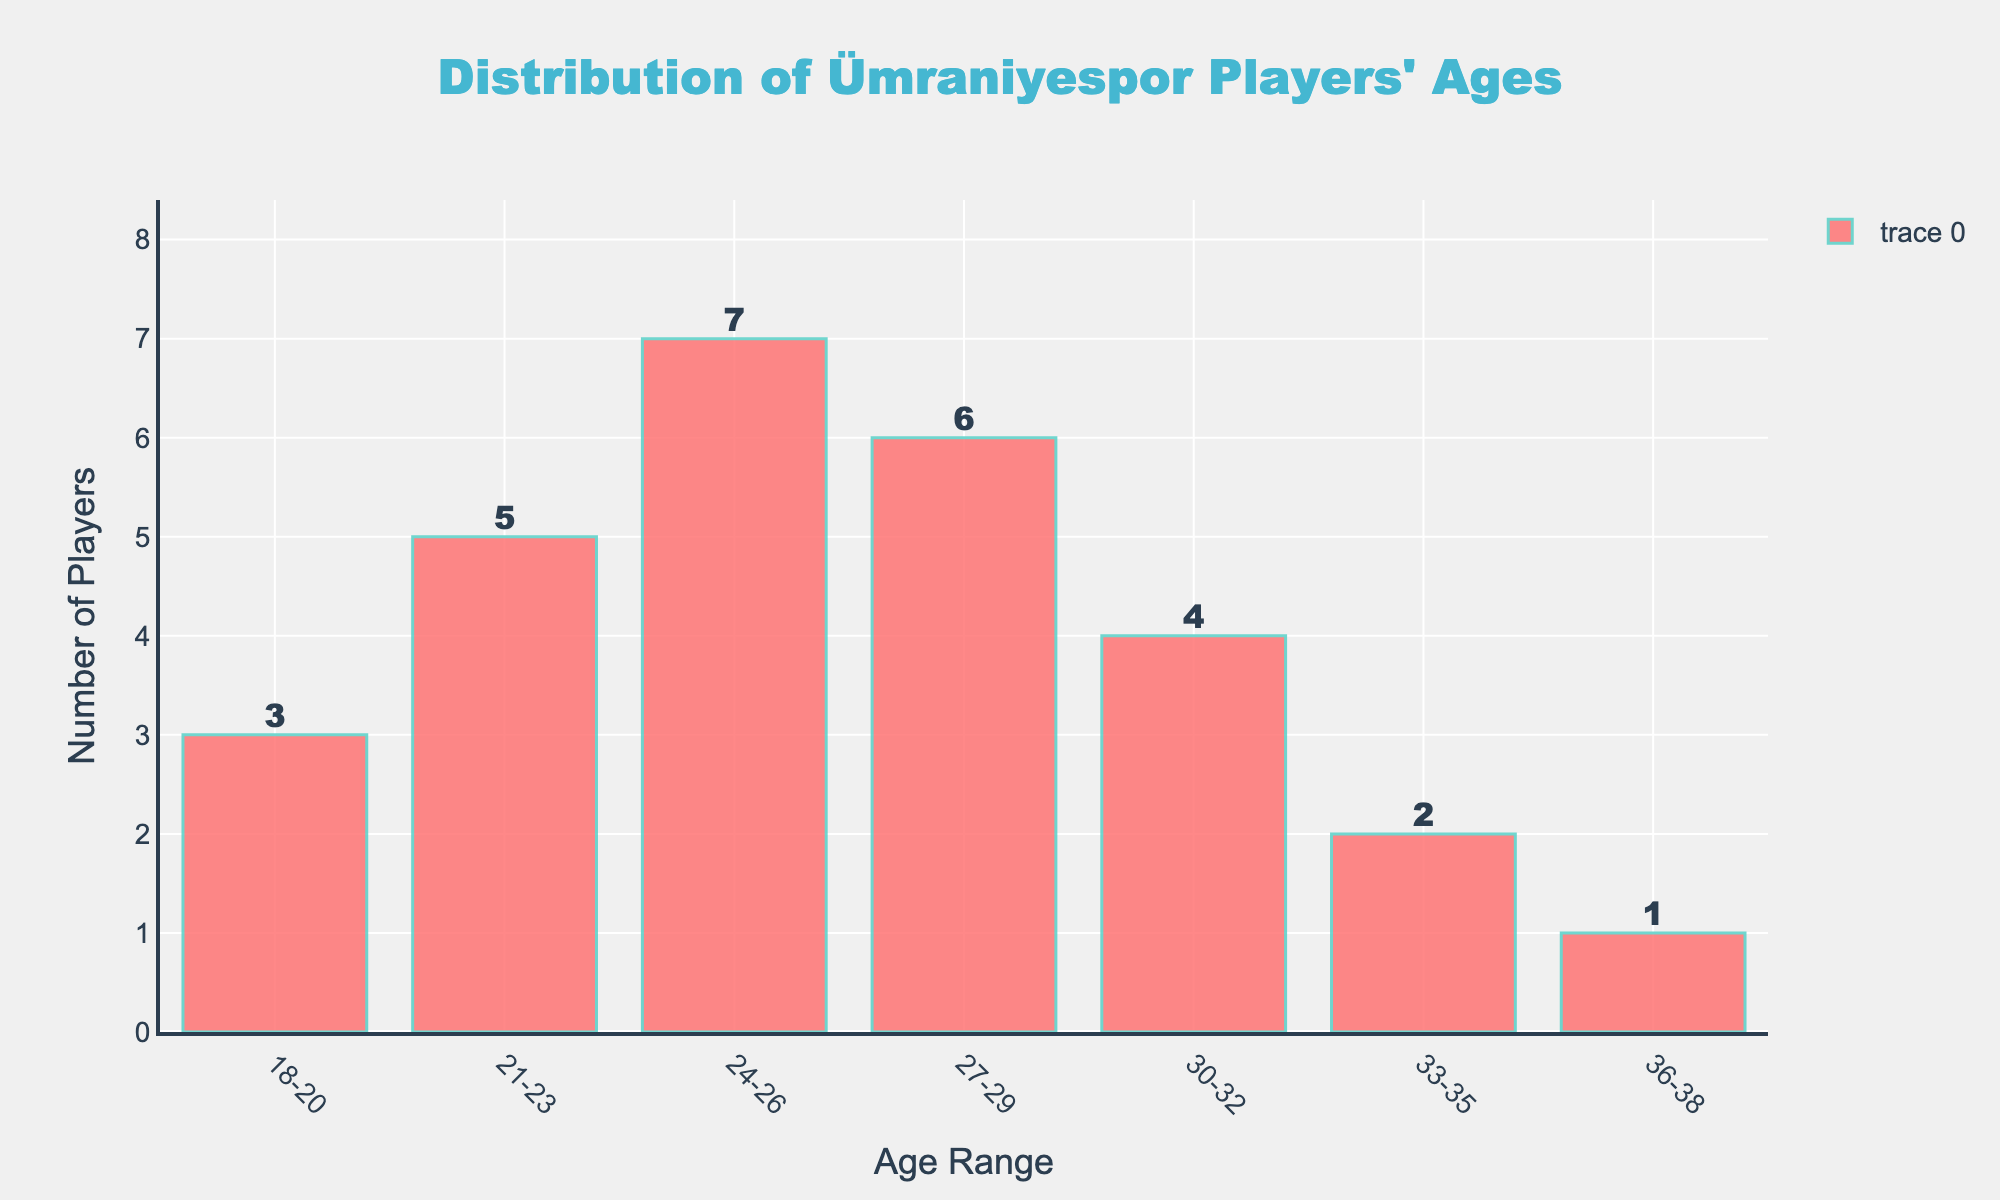What's the total number of Ümraniyespor players aged between 21 and 29? First, add the number of players in the 21-23 and 24-26 age ranges: 5 + 7 = 12. Then, add the players in the 27-29 range: 12 + 6 = 18
Answer: 18 Which age range has the highest number of players? Identify the bar with the tallest height, which corresponds to 24-26 age range with 7 players
Answer: 24-26 How many fewer players are there in the 36-38 age range compared to the 30-32 age range? Subtract the number of players in the 36-38 range from the 30-32 range: 4 - 1 = 3
Answer: 3 What’s the average number of players in the age ranges 24-26, 27-29, and 30-32? Calculate the sum of players in these ranges: 7 + 6 + 4 = 17. Then, divide by the number of age ranges: 17 / 3 ≈ 5.67
Answer: 5.67 Which age ranges have an equal number of Ümraniyespor players? Compare the heights of the bars. Only the bars for age ranges 21-23 and 27-29 are equal, each with 6 players
Answer: 21-23 and 27-29 What’s the ratio of players aged 24-26 to those aged 33-35? Divide the number of players in the 24-26 age range by the number in the 33-35 range: 7 / 2 = 3.5
Answer: 3.5 Which age range has more players: 18-20 or 33-35? Compare the heights of the respective bars: 18-20 with 3 players and 33-35 with 2 players. Thus, 18-20 has more players
Answer: 18-20 How many players are aged 30 or older? Add the number of players in the 30-32, 33-35, and 36-38 ranges: 4 + 2 + 1 = 7
Answer: 7 